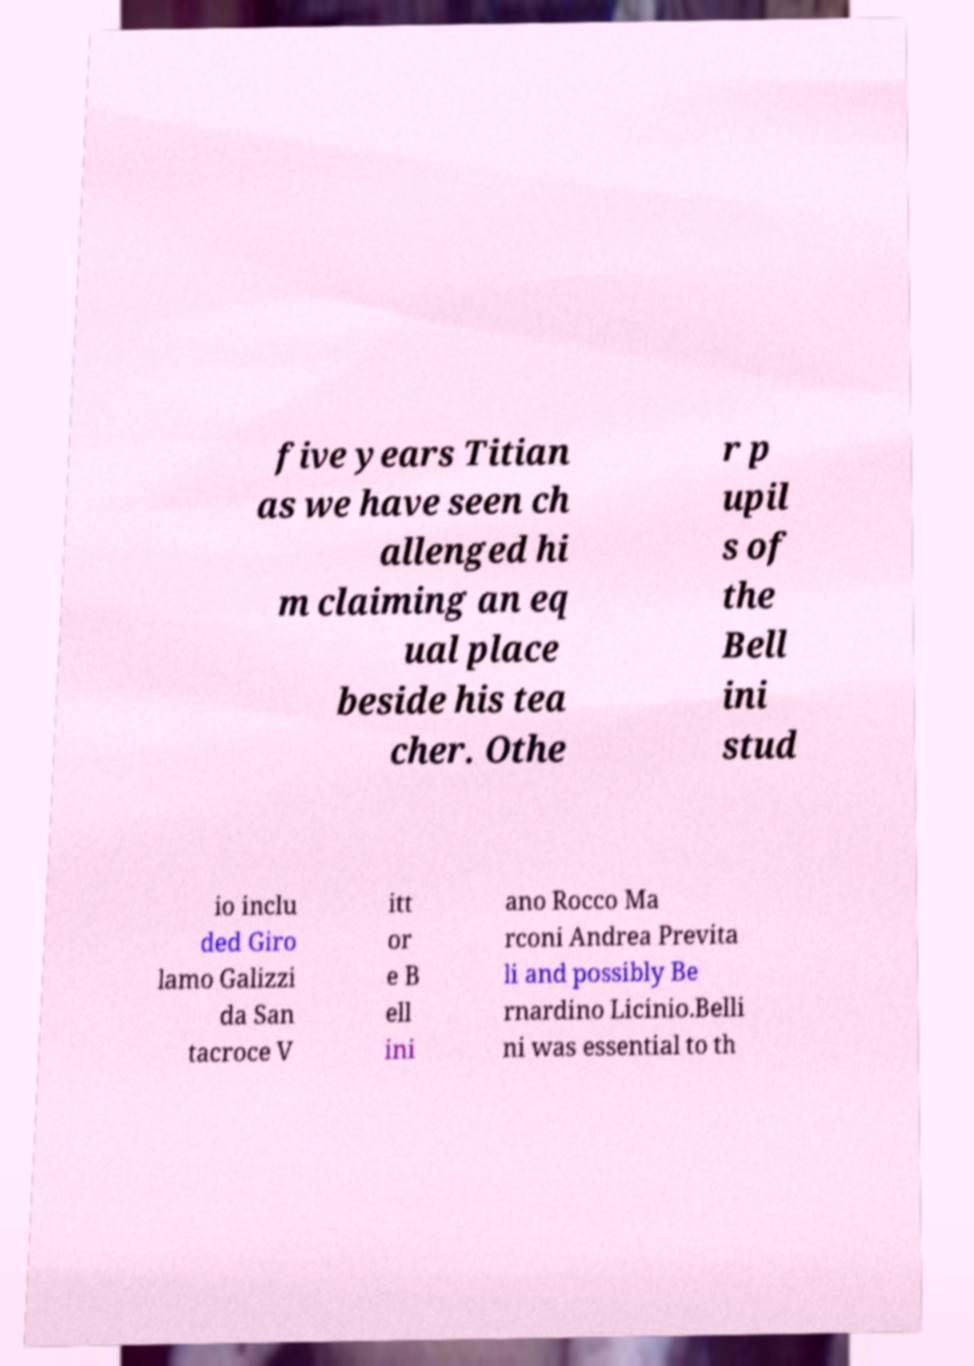There's text embedded in this image that I need extracted. Can you transcribe it verbatim? five years Titian as we have seen ch allenged hi m claiming an eq ual place beside his tea cher. Othe r p upil s of the Bell ini stud io inclu ded Giro lamo Galizzi da San tacroce V itt or e B ell ini ano Rocco Ma rconi Andrea Previta li and possibly Be rnardino Licinio.Belli ni was essential to th 